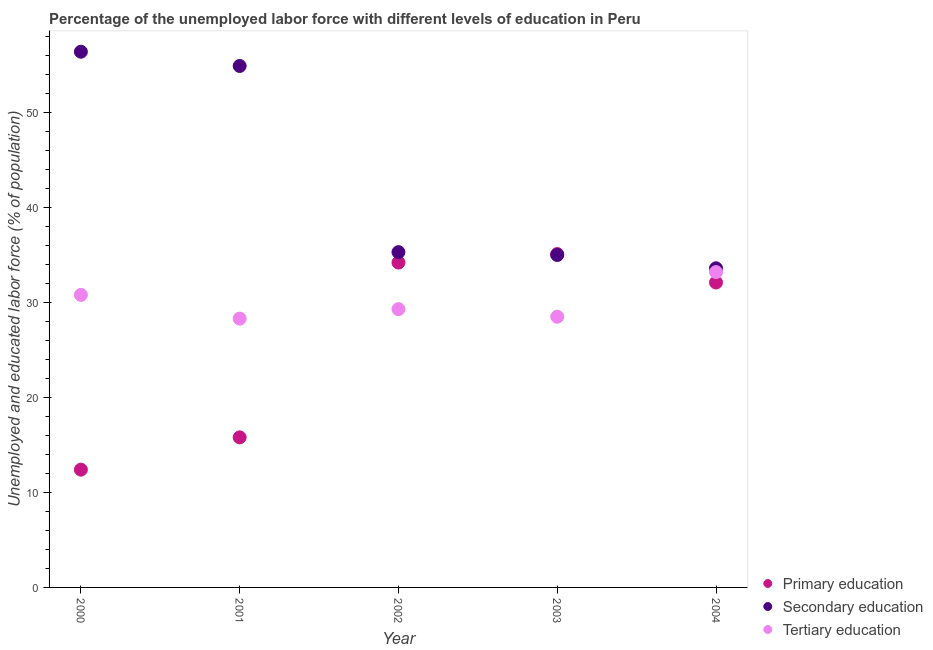What is the percentage of labor force who received secondary education in 2000?
Offer a terse response. 56.4. Across all years, what is the maximum percentage of labor force who received tertiary education?
Offer a very short reply. 33.2. Across all years, what is the minimum percentage of labor force who received tertiary education?
Provide a short and direct response. 28.3. What is the total percentage of labor force who received secondary education in the graph?
Your response must be concise. 215.2. What is the difference between the percentage of labor force who received secondary education in 2000 and that in 2002?
Provide a succinct answer. 21.1. What is the average percentage of labor force who received tertiary education per year?
Your answer should be very brief. 30.02. In the year 2001, what is the difference between the percentage of labor force who received secondary education and percentage of labor force who received primary education?
Offer a very short reply. 39.1. In how many years, is the percentage of labor force who received secondary education greater than 8 %?
Your response must be concise. 5. What is the ratio of the percentage of labor force who received tertiary education in 2001 to that in 2002?
Keep it short and to the point. 0.97. Is the percentage of labor force who received secondary education in 2003 less than that in 2004?
Offer a very short reply. No. Is the difference between the percentage of labor force who received secondary education in 2000 and 2004 greater than the difference between the percentage of labor force who received tertiary education in 2000 and 2004?
Provide a short and direct response. Yes. What is the difference between the highest and the lowest percentage of labor force who received primary education?
Your response must be concise. 22.7. Is the sum of the percentage of labor force who received tertiary education in 2001 and 2002 greater than the maximum percentage of labor force who received secondary education across all years?
Your response must be concise. Yes. Does the percentage of labor force who received tertiary education monotonically increase over the years?
Your response must be concise. No. How many years are there in the graph?
Your answer should be very brief. 5. What is the difference between two consecutive major ticks on the Y-axis?
Provide a short and direct response. 10. Does the graph contain grids?
Your answer should be compact. No. Where does the legend appear in the graph?
Your answer should be very brief. Bottom right. What is the title of the graph?
Offer a terse response. Percentage of the unemployed labor force with different levels of education in Peru. Does "Secondary" appear as one of the legend labels in the graph?
Offer a very short reply. No. What is the label or title of the Y-axis?
Keep it short and to the point. Unemployed and educated labor force (% of population). What is the Unemployed and educated labor force (% of population) of Primary education in 2000?
Provide a short and direct response. 12.4. What is the Unemployed and educated labor force (% of population) of Secondary education in 2000?
Make the answer very short. 56.4. What is the Unemployed and educated labor force (% of population) of Tertiary education in 2000?
Give a very brief answer. 30.8. What is the Unemployed and educated labor force (% of population) in Primary education in 2001?
Offer a terse response. 15.8. What is the Unemployed and educated labor force (% of population) of Secondary education in 2001?
Provide a succinct answer. 54.9. What is the Unemployed and educated labor force (% of population) in Tertiary education in 2001?
Ensure brevity in your answer.  28.3. What is the Unemployed and educated labor force (% of population) in Primary education in 2002?
Ensure brevity in your answer.  34.2. What is the Unemployed and educated labor force (% of population) of Secondary education in 2002?
Make the answer very short. 35.3. What is the Unemployed and educated labor force (% of population) in Tertiary education in 2002?
Provide a short and direct response. 29.3. What is the Unemployed and educated labor force (% of population) of Primary education in 2003?
Give a very brief answer. 35.1. What is the Unemployed and educated labor force (% of population) of Primary education in 2004?
Offer a very short reply. 32.1. What is the Unemployed and educated labor force (% of population) of Secondary education in 2004?
Provide a succinct answer. 33.6. What is the Unemployed and educated labor force (% of population) of Tertiary education in 2004?
Keep it short and to the point. 33.2. Across all years, what is the maximum Unemployed and educated labor force (% of population) in Primary education?
Keep it short and to the point. 35.1. Across all years, what is the maximum Unemployed and educated labor force (% of population) in Secondary education?
Offer a very short reply. 56.4. Across all years, what is the maximum Unemployed and educated labor force (% of population) in Tertiary education?
Offer a very short reply. 33.2. Across all years, what is the minimum Unemployed and educated labor force (% of population) in Primary education?
Keep it short and to the point. 12.4. Across all years, what is the minimum Unemployed and educated labor force (% of population) in Secondary education?
Your answer should be very brief. 33.6. Across all years, what is the minimum Unemployed and educated labor force (% of population) in Tertiary education?
Give a very brief answer. 28.3. What is the total Unemployed and educated labor force (% of population) of Primary education in the graph?
Ensure brevity in your answer.  129.6. What is the total Unemployed and educated labor force (% of population) of Secondary education in the graph?
Ensure brevity in your answer.  215.2. What is the total Unemployed and educated labor force (% of population) of Tertiary education in the graph?
Your answer should be very brief. 150.1. What is the difference between the Unemployed and educated labor force (% of population) in Secondary education in 2000 and that in 2001?
Offer a terse response. 1.5. What is the difference between the Unemployed and educated labor force (% of population) of Tertiary education in 2000 and that in 2001?
Make the answer very short. 2.5. What is the difference between the Unemployed and educated labor force (% of population) in Primary education in 2000 and that in 2002?
Offer a terse response. -21.8. What is the difference between the Unemployed and educated labor force (% of population) of Secondary education in 2000 and that in 2002?
Offer a terse response. 21.1. What is the difference between the Unemployed and educated labor force (% of population) of Primary education in 2000 and that in 2003?
Offer a terse response. -22.7. What is the difference between the Unemployed and educated labor force (% of population) in Secondary education in 2000 and that in 2003?
Give a very brief answer. 21.4. What is the difference between the Unemployed and educated labor force (% of population) in Primary education in 2000 and that in 2004?
Provide a short and direct response. -19.7. What is the difference between the Unemployed and educated labor force (% of population) of Secondary education in 2000 and that in 2004?
Provide a succinct answer. 22.8. What is the difference between the Unemployed and educated labor force (% of population) in Tertiary education in 2000 and that in 2004?
Provide a succinct answer. -2.4. What is the difference between the Unemployed and educated labor force (% of population) of Primary education in 2001 and that in 2002?
Ensure brevity in your answer.  -18.4. What is the difference between the Unemployed and educated labor force (% of population) in Secondary education in 2001 and that in 2002?
Your answer should be compact. 19.6. What is the difference between the Unemployed and educated labor force (% of population) of Primary education in 2001 and that in 2003?
Provide a short and direct response. -19.3. What is the difference between the Unemployed and educated labor force (% of population) in Secondary education in 2001 and that in 2003?
Make the answer very short. 19.9. What is the difference between the Unemployed and educated labor force (% of population) in Primary education in 2001 and that in 2004?
Ensure brevity in your answer.  -16.3. What is the difference between the Unemployed and educated labor force (% of population) of Secondary education in 2001 and that in 2004?
Keep it short and to the point. 21.3. What is the difference between the Unemployed and educated labor force (% of population) in Tertiary education in 2001 and that in 2004?
Make the answer very short. -4.9. What is the difference between the Unemployed and educated labor force (% of population) in Primary education in 2002 and that in 2004?
Ensure brevity in your answer.  2.1. What is the difference between the Unemployed and educated labor force (% of population) in Tertiary education in 2002 and that in 2004?
Make the answer very short. -3.9. What is the difference between the Unemployed and educated labor force (% of population) of Tertiary education in 2003 and that in 2004?
Offer a very short reply. -4.7. What is the difference between the Unemployed and educated labor force (% of population) in Primary education in 2000 and the Unemployed and educated labor force (% of population) in Secondary education in 2001?
Give a very brief answer. -42.5. What is the difference between the Unemployed and educated labor force (% of population) in Primary education in 2000 and the Unemployed and educated labor force (% of population) in Tertiary education in 2001?
Your answer should be very brief. -15.9. What is the difference between the Unemployed and educated labor force (% of population) of Secondary education in 2000 and the Unemployed and educated labor force (% of population) of Tertiary education in 2001?
Give a very brief answer. 28.1. What is the difference between the Unemployed and educated labor force (% of population) of Primary education in 2000 and the Unemployed and educated labor force (% of population) of Secondary education in 2002?
Make the answer very short. -22.9. What is the difference between the Unemployed and educated labor force (% of population) of Primary education in 2000 and the Unemployed and educated labor force (% of population) of Tertiary education in 2002?
Make the answer very short. -16.9. What is the difference between the Unemployed and educated labor force (% of population) in Secondary education in 2000 and the Unemployed and educated labor force (% of population) in Tertiary education in 2002?
Offer a terse response. 27.1. What is the difference between the Unemployed and educated labor force (% of population) of Primary education in 2000 and the Unemployed and educated labor force (% of population) of Secondary education in 2003?
Provide a short and direct response. -22.6. What is the difference between the Unemployed and educated labor force (% of population) in Primary education in 2000 and the Unemployed and educated labor force (% of population) in Tertiary education in 2003?
Provide a succinct answer. -16.1. What is the difference between the Unemployed and educated labor force (% of population) in Secondary education in 2000 and the Unemployed and educated labor force (% of population) in Tertiary education in 2003?
Make the answer very short. 27.9. What is the difference between the Unemployed and educated labor force (% of population) in Primary education in 2000 and the Unemployed and educated labor force (% of population) in Secondary education in 2004?
Provide a short and direct response. -21.2. What is the difference between the Unemployed and educated labor force (% of population) in Primary education in 2000 and the Unemployed and educated labor force (% of population) in Tertiary education in 2004?
Provide a succinct answer. -20.8. What is the difference between the Unemployed and educated labor force (% of population) in Secondary education in 2000 and the Unemployed and educated labor force (% of population) in Tertiary education in 2004?
Provide a succinct answer. 23.2. What is the difference between the Unemployed and educated labor force (% of population) of Primary education in 2001 and the Unemployed and educated labor force (% of population) of Secondary education in 2002?
Offer a very short reply. -19.5. What is the difference between the Unemployed and educated labor force (% of population) in Secondary education in 2001 and the Unemployed and educated labor force (% of population) in Tertiary education in 2002?
Offer a terse response. 25.6. What is the difference between the Unemployed and educated labor force (% of population) in Primary education in 2001 and the Unemployed and educated labor force (% of population) in Secondary education in 2003?
Offer a very short reply. -19.2. What is the difference between the Unemployed and educated labor force (% of population) in Secondary education in 2001 and the Unemployed and educated labor force (% of population) in Tertiary education in 2003?
Give a very brief answer. 26.4. What is the difference between the Unemployed and educated labor force (% of population) of Primary education in 2001 and the Unemployed and educated labor force (% of population) of Secondary education in 2004?
Offer a terse response. -17.8. What is the difference between the Unemployed and educated labor force (% of population) in Primary education in 2001 and the Unemployed and educated labor force (% of population) in Tertiary education in 2004?
Your answer should be very brief. -17.4. What is the difference between the Unemployed and educated labor force (% of population) of Secondary education in 2001 and the Unemployed and educated labor force (% of population) of Tertiary education in 2004?
Your answer should be compact. 21.7. What is the difference between the Unemployed and educated labor force (% of population) in Secondary education in 2002 and the Unemployed and educated labor force (% of population) in Tertiary education in 2004?
Provide a short and direct response. 2.1. What is the difference between the Unemployed and educated labor force (% of population) of Primary education in 2003 and the Unemployed and educated labor force (% of population) of Secondary education in 2004?
Offer a terse response. 1.5. What is the average Unemployed and educated labor force (% of population) in Primary education per year?
Make the answer very short. 25.92. What is the average Unemployed and educated labor force (% of population) in Secondary education per year?
Keep it short and to the point. 43.04. What is the average Unemployed and educated labor force (% of population) in Tertiary education per year?
Ensure brevity in your answer.  30.02. In the year 2000, what is the difference between the Unemployed and educated labor force (% of population) in Primary education and Unemployed and educated labor force (% of population) in Secondary education?
Offer a terse response. -44. In the year 2000, what is the difference between the Unemployed and educated labor force (% of population) in Primary education and Unemployed and educated labor force (% of population) in Tertiary education?
Give a very brief answer. -18.4. In the year 2000, what is the difference between the Unemployed and educated labor force (% of population) in Secondary education and Unemployed and educated labor force (% of population) in Tertiary education?
Offer a terse response. 25.6. In the year 2001, what is the difference between the Unemployed and educated labor force (% of population) in Primary education and Unemployed and educated labor force (% of population) in Secondary education?
Your answer should be very brief. -39.1. In the year 2001, what is the difference between the Unemployed and educated labor force (% of population) in Secondary education and Unemployed and educated labor force (% of population) in Tertiary education?
Your answer should be very brief. 26.6. In the year 2002, what is the difference between the Unemployed and educated labor force (% of population) in Primary education and Unemployed and educated labor force (% of population) in Secondary education?
Give a very brief answer. -1.1. In the year 2002, what is the difference between the Unemployed and educated labor force (% of population) of Secondary education and Unemployed and educated labor force (% of population) of Tertiary education?
Your answer should be compact. 6. In the year 2003, what is the difference between the Unemployed and educated labor force (% of population) in Primary education and Unemployed and educated labor force (% of population) in Secondary education?
Keep it short and to the point. 0.1. In the year 2004, what is the difference between the Unemployed and educated labor force (% of population) of Secondary education and Unemployed and educated labor force (% of population) of Tertiary education?
Keep it short and to the point. 0.4. What is the ratio of the Unemployed and educated labor force (% of population) in Primary education in 2000 to that in 2001?
Your answer should be very brief. 0.78. What is the ratio of the Unemployed and educated labor force (% of population) of Secondary education in 2000 to that in 2001?
Your answer should be compact. 1.03. What is the ratio of the Unemployed and educated labor force (% of population) of Tertiary education in 2000 to that in 2001?
Your response must be concise. 1.09. What is the ratio of the Unemployed and educated labor force (% of population) of Primary education in 2000 to that in 2002?
Keep it short and to the point. 0.36. What is the ratio of the Unemployed and educated labor force (% of population) of Secondary education in 2000 to that in 2002?
Provide a succinct answer. 1.6. What is the ratio of the Unemployed and educated labor force (% of population) of Tertiary education in 2000 to that in 2002?
Provide a short and direct response. 1.05. What is the ratio of the Unemployed and educated labor force (% of population) of Primary education in 2000 to that in 2003?
Provide a short and direct response. 0.35. What is the ratio of the Unemployed and educated labor force (% of population) of Secondary education in 2000 to that in 2003?
Keep it short and to the point. 1.61. What is the ratio of the Unemployed and educated labor force (% of population) in Tertiary education in 2000 to that in 2003?
Ensure brevity in your answer.  1.08. What is the ratio of the Unemployed and educated labor force (% of population) in Primary education in 2000 to that in 2004?
Keep it short and to the point. 0.39. What is the ratio of the Unemployed and educated labor force (% of population) of Secondary education in 2000 to that in 2004?
Provide a short and direct response. 1.68. What is the ratio of the Unemployed and educated labor force (% of population) in Tertiary education in 2000 to that in 2004?
Your answer should be very brief. 0.93. What is the ratio of the Unemployed and educated labor force (% of population) of Primary education in 2001 to that in 2002?
Offer a terse response. 0.46. What is the ratio of the Unemployed and educated labor force (% of population) of Secondary education in 2001 to that in 2002?
Offer a terse response. 1.56. What is the ratio of the Unemployed and educated labor force (% of population) in Tertiary education in 2001 to that in 2002?
Provide a short and direct response. 0.97. What is the ratio of the Unemployed and educated labor force (% of population) in Primary education in 2001 to that in 2003?
Offer a terse response. 0.45. What is the ratio of the Unemployed and educated labor force (% of population) of Secondary education in 2001 to that in 2003?
Keep it short and to the point. 1.57. What is the ratio of the Unemployed and educated labor force (% of population) of Tertiary education in 2001 to that in 2003?
Provide a succinct answer. 0.99. What is the ratio of the Unemployed and educated labor force (% of population) of Primary education in 2001 to that in 2004?
Provide a succinct answer. 0.49. What is the ratio of the Unemployed and educated labor force (% of population) in Secondary education in 2001 to that in 2004?
Provide a short and direct response. 1.63. What is the ratio of the Unemployed and educated labor force (% of population) in Tertiary education in 2001 to that in 2004?
Provide a short and direct response. 0.85. What is the ratio of the Unemployed and educated labor force (% of population) of Primary education in 2002 to that in 2003?
Your response must be concise. 0.97. What is the ratio of the Unemployed and educated labor force (% of population) in Secondary education in 2002 to that in 2003?
Provide a succinct answer. 1.01. What is the ratio of the Unemployed and educated labor force (% of population) in Tertiary education in 2002 to that in 2003?
Provide a short and direct response. 1.03. What is the ratio of the Unemployed and educated labor force (% of population) in Primary education in 2002 to that in 2004?
Offer a terse response. 1.07. What is the ratio of the Unemployed and educated labor force (% of population) in Secondary education in 2002 to that in 2004?
Your answer should be compact. 1.05. What is the ratio of the Unemployed and educated labor force (% of population) of Tertiary education in 2002 to that in 2004?
Provide a succinct answer. 0.88. What is the ratio of the Unemployed and educated labor force (% of population) of Primary education in 2003 to that in 2004?
Keep it short and to the point. 1.09. What is the ratio of the Unemployed and educated labor force (% of population) in Secondary education in 2003 to that in 2004?
Provide a short and direct response. 1.04. What is the ratio of the Unemployed and educated labor force (% of population) in Tertiary education in 2003 to that in 2004?
Your answer should be compact. 0.86. What is the difference between the highest and the second highest Unemployed and educated labor force (% of population) in Primary education?
Provide a succinct answer. 0.9. What is the difference between the highest and the lowest Unemployed and educated labor force (% of population) in Primary education?
Make the answer very short. 22.7. What is the difference between the highest and the lowest Unemployed and educated labor force (% of population) in Secondary education?
Offer a terse response. 22.8. What is the difference between the highest and the lowest Unemployed and educated labor force (% of population) of Tertiary education?
Your answer should be very brief. 4.9. 